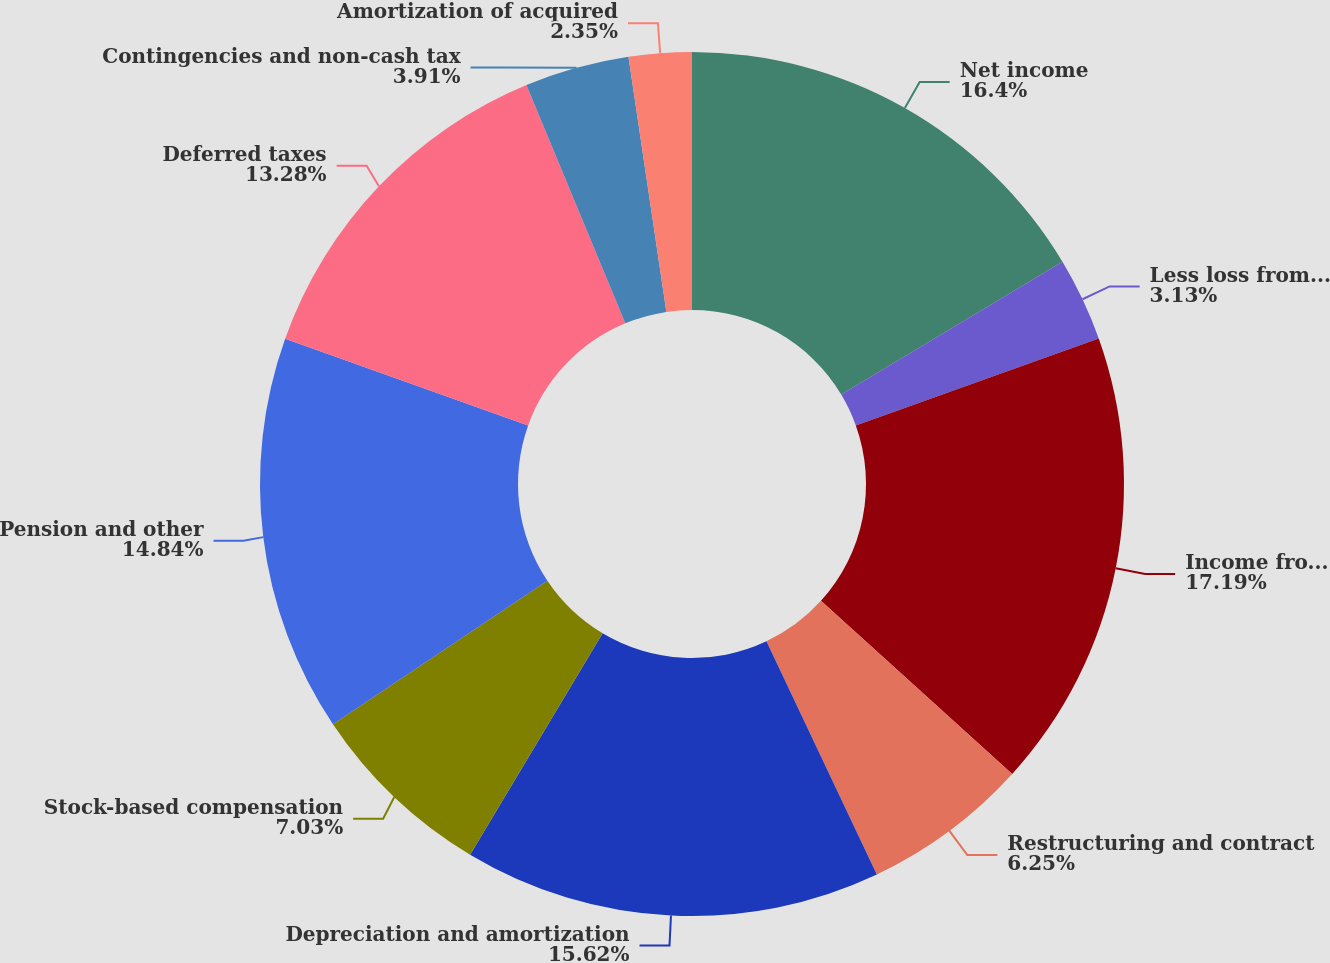<chart> <loc_0><loc_0><loc_500><loc_500><pie_chart><fcel>Net income<fcel>Less loss from discontinued<fcel>Income from continuing<fcel>Restructuring and contract<fcel>Depreciation and amortization<fcel>Stock-based compensation<fcel>Pension and other<fcel>Deferred taxes<fcel>Contingencies and non-cash tax<fcel>Amortization of acquired<nl><fcel>16.4%<fcel>3.13%<fcel>17.18%<fcel>6.25%<fcel>15.62%<fcel>7.03%<fcel>14.84%<fcel>13.28%<fcel>3.91%<fcel>2.35%<nl></chart> 